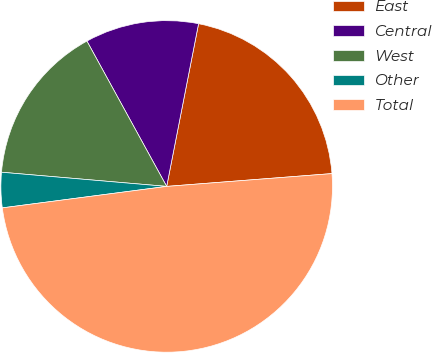Convert chart. <chart><loc_0><loc_0><loc_500><loc_500><pie_chart><fcel>East<fcel>Central<fcel>West<fcel>Other<fcel>Total<nl><fcel>20.69%<fcel>11.07%<fcel>15.65%<fcel>3.43%<fcel>49.17%<nl></chart> 